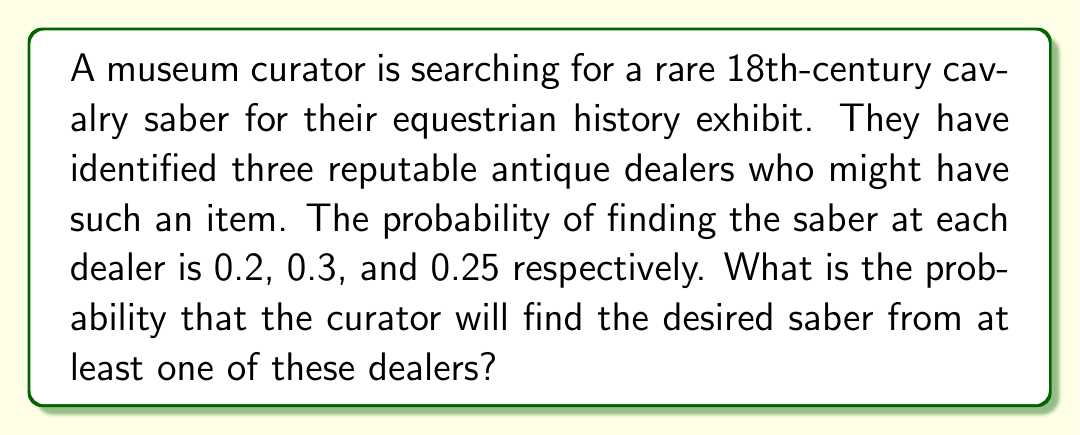Could you help me with this problem? Let's approach this step-by-step:

1) First, we need to calculate the probability of not finding the saber at each dealer:
   Dealer 1: $1 - 0.2 = 0.8$
   Dealer 2: $1 - 0.3 = 0.7$
   Dealer 3: $1 - 0.25 = 0.75$

2) The probability of not finding the saber at any of the dealers is the product of these probabilities:
   $P(\text{not finding}) = 0.8 \times 0.7 \times 0.75 = 0.42$

3) Therefore, the probability of finding the saber at at least one dealer is the complement of this probability:
   $P(\text{finding}) = 1 - P(\text{not finding}) = 1 - 0.42 = 0.58$

4) We can also calculate this using the inclusion-exclusion principle:
   $$\begin{align}
   P(\text{finding}) &= P(A \cup B \cup C) \\
   &= P(A) + P(B) + P(C) - P(A \cap B) - P(A \cap C) - P(B \cap C) + P(A \cap B \cap C) \\
   &= 0.2 + 0.3 + 0.25 - (0.2 \times 0.3) - (0.2 \times 0.25) - (0.3 \times 0.25) + (0.2 \times 0.3 \times 0.25) \\
   &= 0.75 - 0.06 - 0.05 - 0.075 + 0.015 \\
   &= 0.58
   \end{align}$$

Both methods yield the same result, confirming our calculation.
Answer: 0.58 